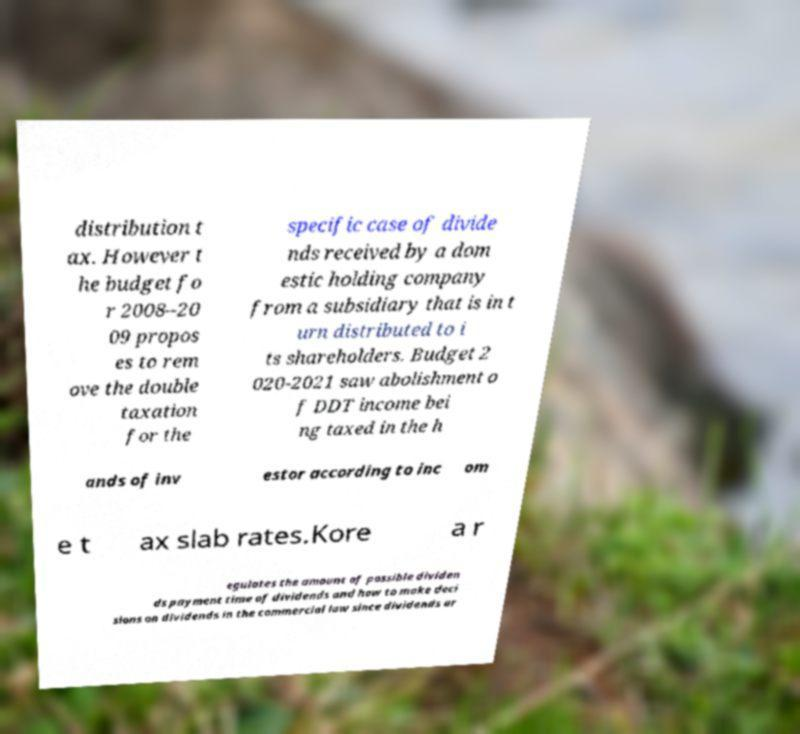I need the written content from this picture converted into text. Can you do that? distribution t ax. However t he budget fo r 2008–20 09 propos es to rem ove the double taxation for the specific case of divide nds received by a dom estic holding company from a subsidiary that is in t urn distributed to i ts shareholders. Budget 2 020-2021 saw abolishment o f DDT income bei ng taxed in the h ands of inv estor according to inc om e t ax slab rates.Kore a r egulates the amount of possible dividen ds payment time of dividends and how to make deci sions on dividends in the commercial law since dividends ar 